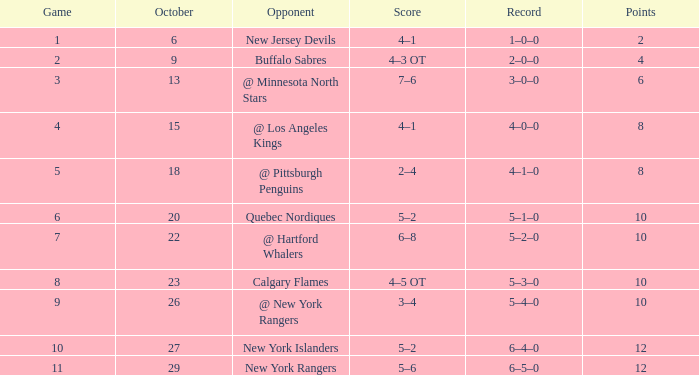In which october is there a 5-1-0 record and a game greater than 6? None. 